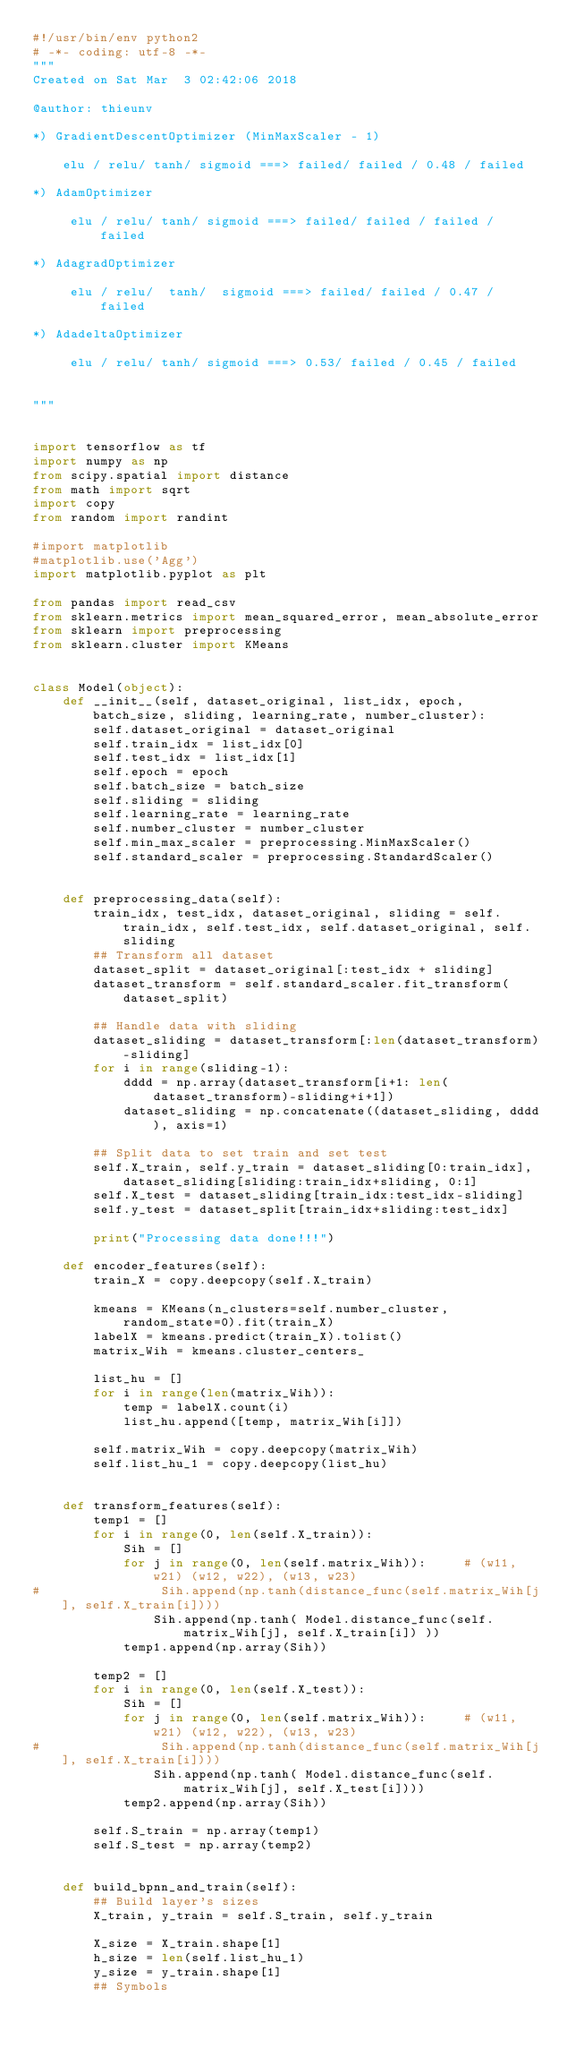<code> <loc_0><loc_0><loc_500><loc_500><_Python_>#!/usr/bin/env python2
# -*- coding: utf-8 -*-
"""
Created on Sat Mar  3 02:42:06 2018

@author: thieunv

*) GradientDescentOptimizer (MinMaxScaler - 1)

    elu / relu/ tanh/ sigmoid ===> failed/ failed / 0.48 / failed
    
*) AdamOptimizer 
    
     elu / relu/ tanh/ sigmoid ===> failed/ failed / failed / failed
    
*) AdagradOptimizer   
    
     elu / relu/  tanh/  sigmoid ===> failed/ failed / 0.47 / failed

*) AdadeltaOptimizer
    
     elu / relu/ tanh/ sigmoid ===> 0.53/ failed / 0.45 / failed
    
    
"""


import tensorflow as tf
import numpy as np
from scipy.spatial import distance
from math import sqrt
import copy
from random import randint

#import matplotlib
#matplotlib.use('Agg')
import matplotlib.pyplot as plt

from pandas import read_csv
from sklearn.metrics import mean_squared_error, mean_absolute_error
from sklearn import preprocessing
from sklearn.cluster import KMeans


class Model(object):
    def __init__(self, dataset_original, list_idx, epoch, batch_size, sliding, learning_rate, number_cluster):
        self.dataset_original = dataset_original
        self.train_idx = list_idx[0]
        self.test_idx = list_idx[1]
        self.epoch = epoch
        self.batch_size = batch_size
        self.sliding = sliding
        self.learning_rate = learning_rate
        self.number_cluster = number_cluster
        self.min_max_scaler = preprocessing.MinMaxScaler()
        self.standard_scaler = preprocessing.StandardScaler()
        
    
    def preprocessing_data(self):
        train_idx, test_idx, dataset_original, sliding = self.train_idx, self.test_idx, self.dataset_original, self.sliding
        ## Transform all dataset
        dataset_split = dataset_original[:test_idx + sliding]
        dataset_transform = self.standard_scaler.fit_transform(dataset_split)
        
        ## Handle data with sliding
        dataset_sliding = dataset_transform[:len(dataset_transform)-sliding]
        for i in range(sliding-1):
            dddd = np.array(dataset_transform[i+1: len(dataset_transform)-sliding+i+1])
            dataset_sliding = np.concatenate((dataset_sliding, dddd), axis=1)
            
        ## Split data to set train and set test
        self.X_train, self.y_train = dataset_sliding[0:train_idx], dataset_sliding[sliding:train_idx+sliding, 0:1]
        self.X_test = dataset_sliding[train_idx:test_idx-sliding]
        self.y_test = dataset_split[train_idx+sliding:test_idx]
        
        print("Processing data done!!!")
    
    def encoder_features(self):
        train_X = copy.deepcopy(self.X_train)

        kmeans = KMeans(n_clusters=self.number_cluster, random_state=0).fit(train_X)
        labelX = kmeans.predict(train_X).tolist()
        matrix_Wih = kmeans.cluster_centers_
        
        list_hu = []
        for i in range(len(matrix_Wih)):
            temp = labelX.count(i)
            list_hu.append([temp, matrix_Wih[i]])
        
        self.matrix_Wih = copy.deepcopy(matrix_Wih)
        self.list_hu_1 = copy.deepcopy(list_hu)
        
    
    def transform_features(self):
        temp1 = []
        for i in range(0, len(self.X_train)):  
            Sih = []
            for j in range(0, len(self.matrix_Wih)):     # (w11, w21) (w12, w22), (w13, w23)
#                Sih.append(np.tanh(distance_func(self.matrix_Wih[j], self.X_train[i])))
                Sih.append(np.tanh( Model.distance_func(self.matrix_Wih[j], self.X_train[i]) ))
            temp1.append(np.array(Sih))
        
        temp2 = []
        for i in range(0, len(self.X_test)):  
            Sih = []
            for j in range(0, len(self.matrix_Wih)):     # (w11, w21) (w12, w22), (w13, w23)
#                Sih.append(np.tanh(distance_func(self.matrix_Wih[j], self.X_train[i])))
                Sih.append(np.tanh( Model.distance_func(self.matrix_Wih[j], self.X_test[i])))
            temp2.append(np.array(Sih))
            
        self.S_train = np.array(temp1)
        self.S_test = np.array(temp2)
    
    
    def build_bpnn_and_train(self):
        ## Build layer's sizes
        X_train, y_train = self.S_train, self.y_train

        X_size = X_train.shape[1]   
        h_size = len(self.list_hu_1)
        y_size = y_train.shape[1]
        ## Symbols</code> 